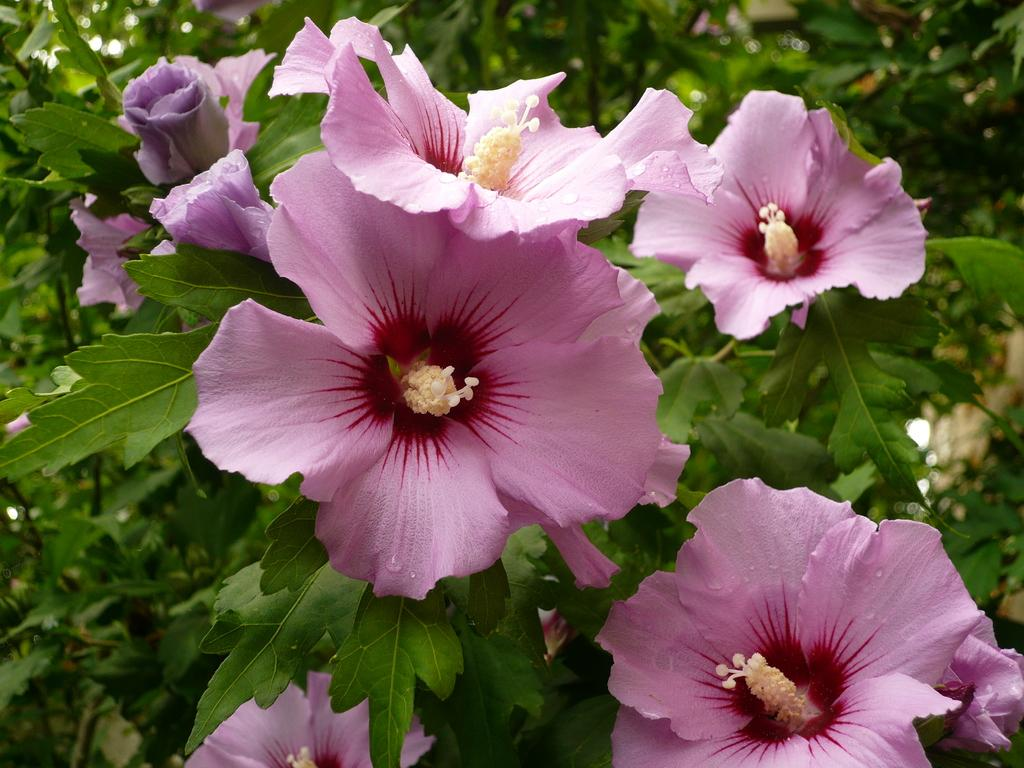What type of plants can be seen in the image? There are flower plants in the image. What color are the flowers on the plants? The flowers are pink in color. What type of popcorn is being served by the secretary during the thunderstorm in the image? There is no secretary, popcorn, or thunderstorm present in the image; it features flower plants with pink flowers. 